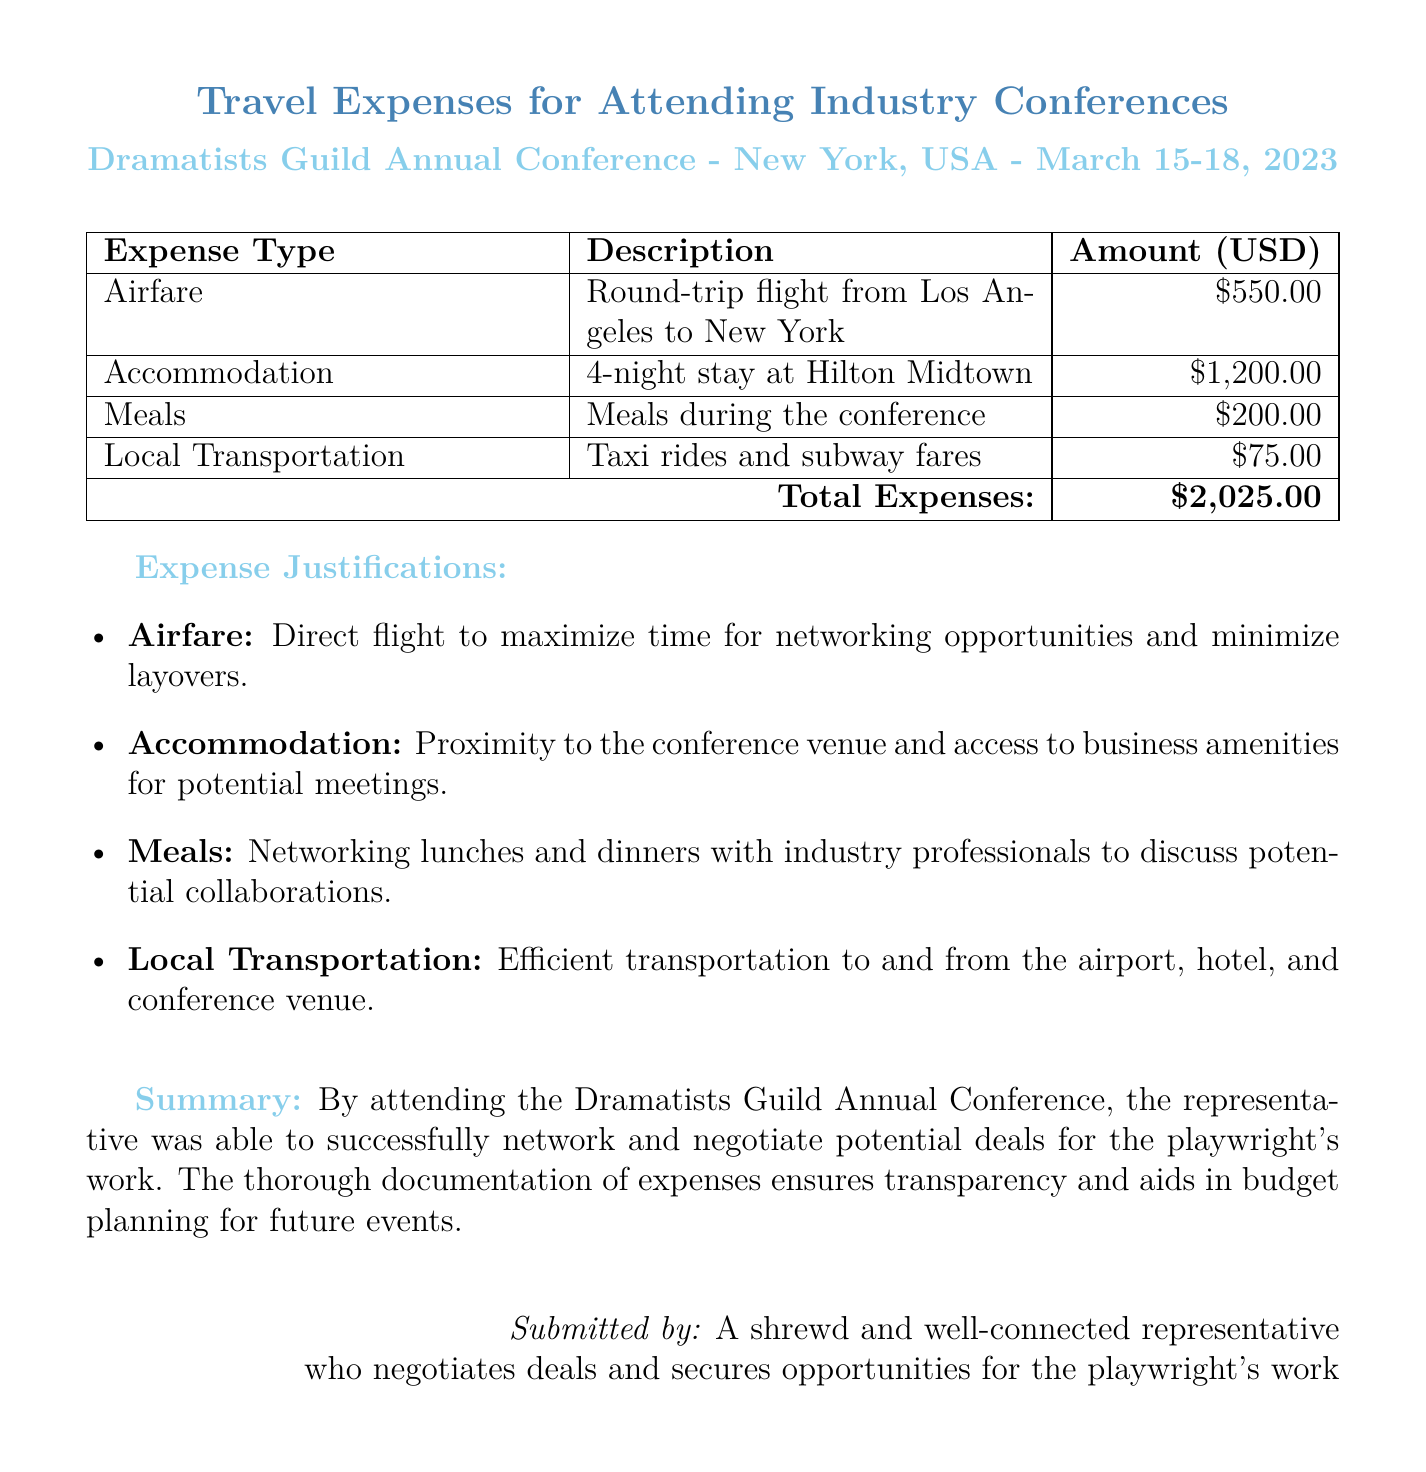What is the total amount of travel expenses? The total amount of travel expenses is calculated by summing all individual expenses listed in the document.
Answer: $2,025.00 What is the airfare cost? The airfare cost is specifically listed in the document as a separate entry.
Answer: $550.00 How many nights did the representative stay in the hotel? The number of nights stayed at the hotel is detailed in the accommodation entry.
Answer: 4 What city was the conference held in? The city of the conference is mentioned in the header of the document.
Answer: New York What type of meals were included in the expenses? The meals included in the expenses refer to networking opportunities mentioned in the justifications.
Answer: Meals during the conference What is the date range of the conference? The date range of the conference can be found in the header of the document.
Answer: March 15-18, 2023 What reason is given for selecting the airfare? The justification for selecting the airfare is provided in the expense justifications section.
Answer: Maximize time for networking opportunities What type of local transportation was used? The local transportation entries specify the methods of transportation used during the trip.
Answer: Taxi rides and subway fares Who submitted the expense report? The name of the person submitting the expense report can be found in the footer of the document.
Answer: A shrewd and well-connected representative 